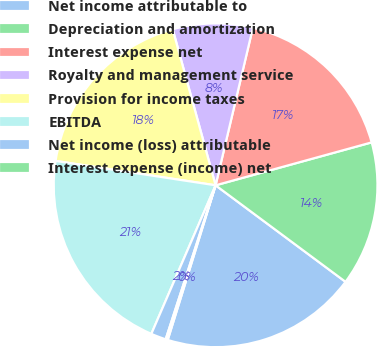Convert chart to OTSL. <chart><loc_0><loc_0><loc_500><loc_500><pie_chart><fcel>Net income attributable to<fcel>Depreciation and amortization<fcel>Interest expense net<fcel>Royalty and management service<fcel>Provision for income taxes<fcel>EBITDA<fcel>Net income (loss) attributable<fcel>Interest expense (income) net<nl><fcel>19.61%<fcel>14.44%<fcel>17.03%<fcel>7.97%<fcel>18.32%<fcel>20.91%<fcel>1.51%<fcel>0.21%<nl></chart> 